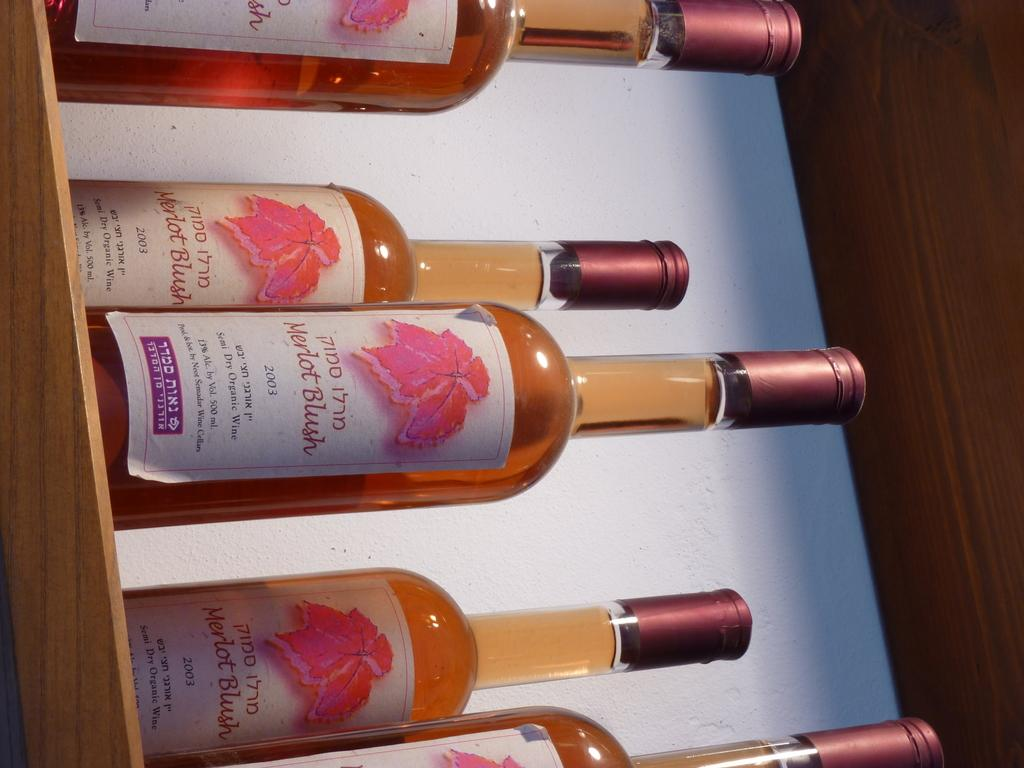Provide a one-sentence caption for the provided image. Bottles of wine from 2003 with 13 % alcohol on a shelf. 